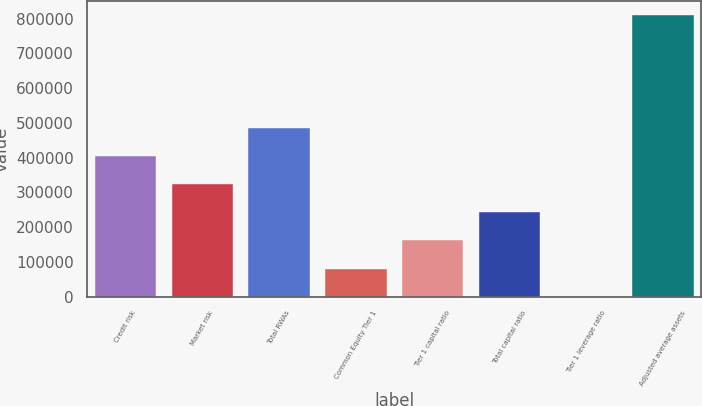Convert chart. <chart><loc_0><loc_0><loc_500><loc_500><bar_chart><fcel>Credit risk<fcel>Market risk<fcel>Total RWAs<fcel>Common Equity Tier 1<fcel>Tier 1 capital ratio<fcel>Total capital ratio<fcel>Tier 1 leverage ratio<fcel>Adjusted average assets<nl><fcel>405266<fcel>324214<fcel>486318<fcel>81059.5<fcel>162111<fcel>243163<fcel>7.9<fcel>810524<nl></chart> 